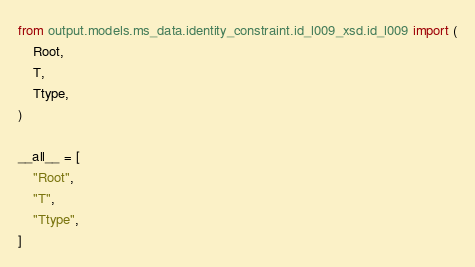<code> <loc_0><loc_0><loc_500><loc_500><_Python_>from output.models.ms_data.identity_constraint.id_l009_xsd.id_l009 import (
    Root,
    T,
    Ttype,
)

__all__ = [
    "Root",
    "T",
    "Ttype",
]
</code> 